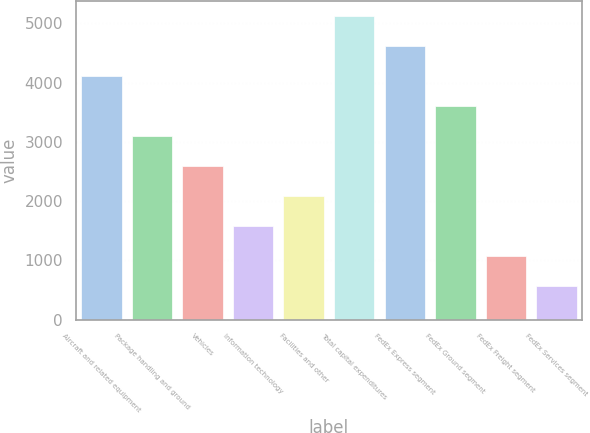<chart> <loc_0><loc_0><loc_500><loc_500><bar_chart><fcel>Aircraft and related equipment<fcel>Package handling and ground<fcel>Vehicles<fcel>Information technology<fcel>Facilities and other<fcel>Total capital expenditures<fcel>FedEx Express segment<fcel>FedEx Ground segment<fcel>FedEx Freight segment<fcel>FedEx Services segment<nl><fcel>4103.6<fcel>3091.2<fcel>2585<fcel>1572.6<fcel>2078.8<fcel>5116<fcel>4609.8<fcel>3597.4<fcel>1066.4<fcel>560.2<nl></chart> 